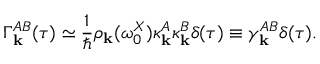<formula> <loc_0><loc_0><loc_500><loc_500>\Gamma _ { k } ^ { A B } ( \tau ) \simeq \frac { 1 } { } \rho _ { k } ( \omega _ { 0 } ^ { X } ) \kappa _ { k } ^ { A } \kappa _ { k } ^ { B } \delta ( \tau ) \equiv \gamma _ { k } ^ { A B } \delta ( \tau ) .</formula> 